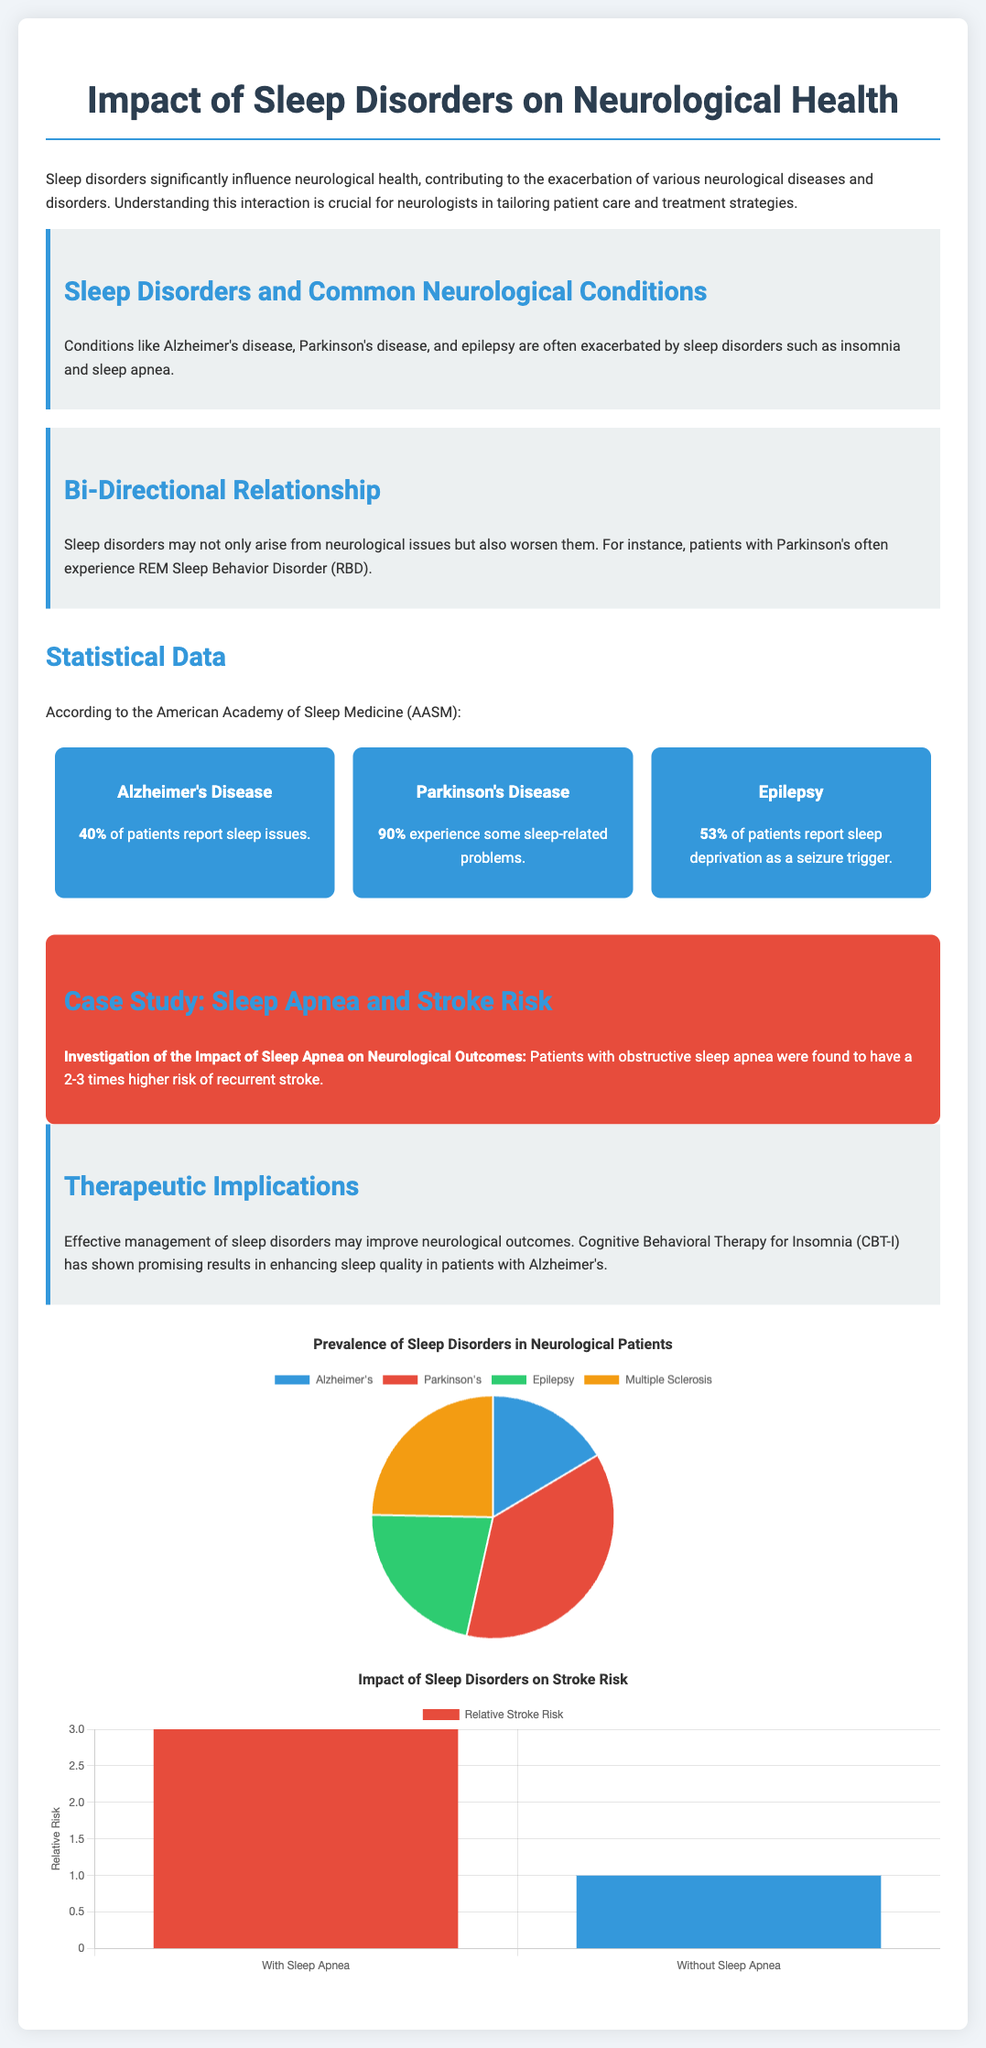What percentage of Alzheimer's patients report sleep issues? The document states that 40% of Alzheimer's patients report sleep issues, which is a statistic listed in the statistical data section.
Answer: 40% What is the risk increase of recurrent stroke associated with sleep apnea? The case study indicates that patients with obstructive sleep apnea have a 2-3 times higher risk of recurrent stroke, detailing the impact of sleep apnea on neurological outcomes.
Answer: 2-3 times Which neurological condition has the highest reported sleep-related problems? According to the statistical data, Parkinson's Disease has the highest percentage of patients, with 90% experiencing some sleep-related problems.
Answer: 90% What therapy has shown promising results for enhancing sleep quality in Alzheimer's patients? The document mentions that Cognitive Behavioral Therapy for Insomnia (CBT-I) has shown promising results, which is noted in the therapeutic implications section.
Answer: Cognitive Behavioral Therapy for Insomnia (CBT-I) What is the prevalence percentage of sleep deprivation as a seizure trigger in epilepsy patients? The document indicates that 53% of epilepsy patients report sleep deprivation as a seizure trigger, found in the statistical data.
Answer: 53% How many neurological conditions are specifically mentioned in relation to sleep disorders? The document lists three conditions explicitly: Alzheimer's disease, Parkinson's disease, and epilepsy, making it clear in the key point section discussing sleep disorders and common neurological conditions.
Answer: Three Which two categories are compared in the stroke risk chart? The stroke risk chart compares the categories "With Sleep Apnea" and "Without Sleep Apnea," as referenced in the chart section of the document.
Answer: With Sleep Apnea and Without Sleep Apnea What is the main focus of the presentation slides? The slides focus on the impact of sleep disorders on neurological health, as stated in the title and introductory paragraph of the document.
Answer: The impact of sleep disorders on neurological health 